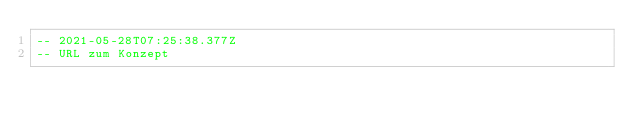Convert code to text. <code><loc_0><loc_0><loc_500><loc_500><_SQL_>-- 2021-05-28T07:25:38.377Z
-- URL zum Konzept</code> 